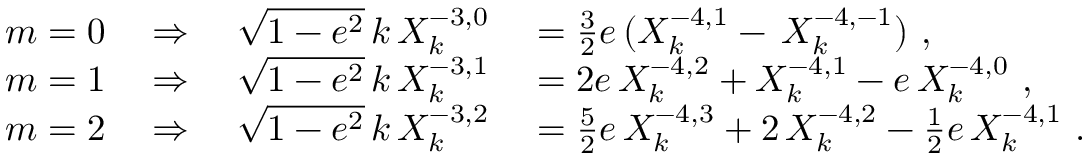<formula> <loc_0><loc_0><loc_500><loc_500>\begin{array} { r l } { m = 0 \quad \Rightarrow \quad \sqrt { 1 - e ^ { 2 } } \, k \, X _ { k } ^ { - 3 , 0 } } & = \frac { 3 } { 2 } e \, ( X _ { k } ^ { - 4 , 1 } - \, X _ { k } ^ { - 4 , - 1 } ) \ , } \\ { m = 1 \quad \Rightarrow \quad \sqrt { 1 - e ^ { 2 } } \, k \, X _ { k } ^ { - 3 , 1 } } & = 2 e \, X _ { k } ^ { - 4 , 2 } + X _ { k } ^ { - 4 , 1 } - e \, X _ { k } ^ { - 4 , 0 } \ , } \\ { m = 2 \quad \Rightarrow \quad \sqrt { 1 - e ^ { 2 } } \, k \, X _ { k } ^ { - 3 , 2 } } & = \frac { 5 } { 2 } e \, X _ { k } ^ { - 4 , 3 } + 2 \, X _ { k } ^ { - 4 , 2 } - \frac { 1 } { 2 } e \, X _ { k } ^ { - 4 , 1 } \ . } \end{array}</formula> 